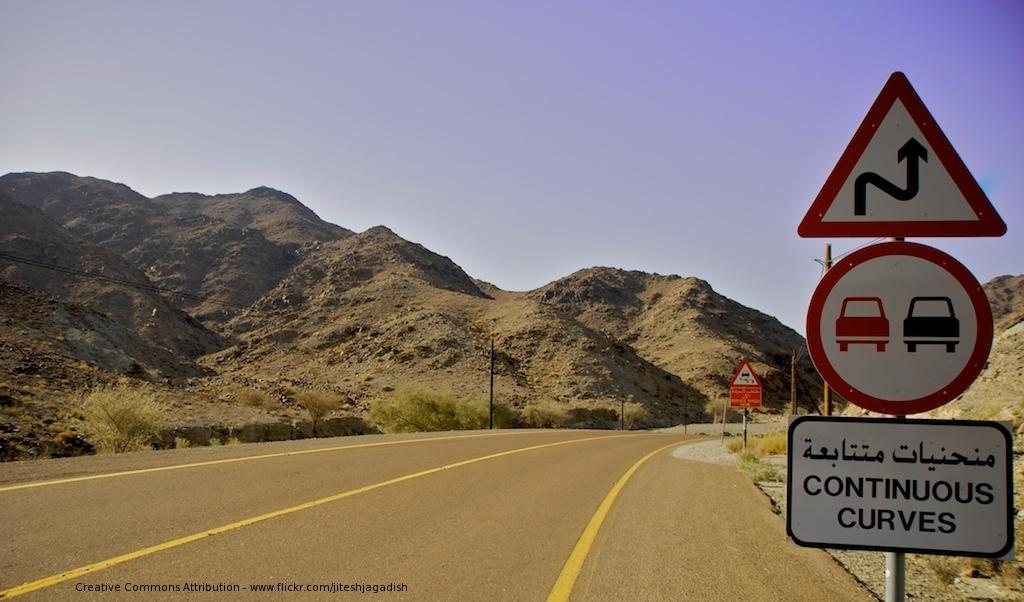Provide a one-sentence caption for the provided image. The sign next to this roadway warns drivers that the road is very curvy up ahead. 